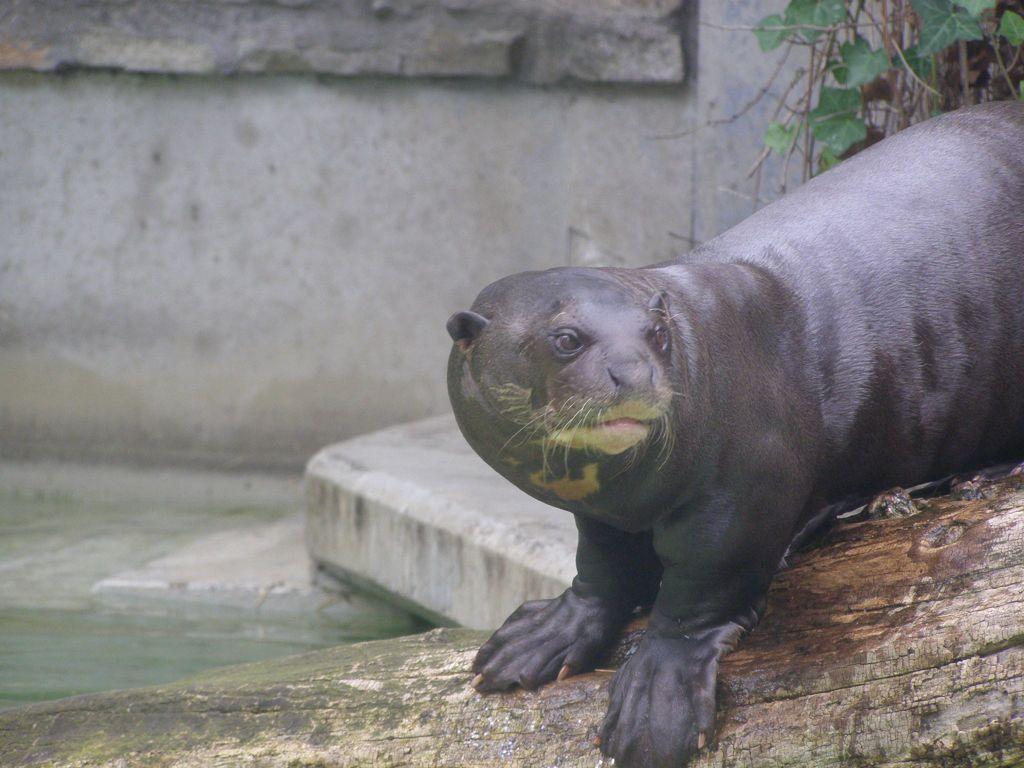In one or two sentences, can you explain what this image depicts? This image consists of an animal. That looks like a seal. It is in black color. There is a plant at the top. 